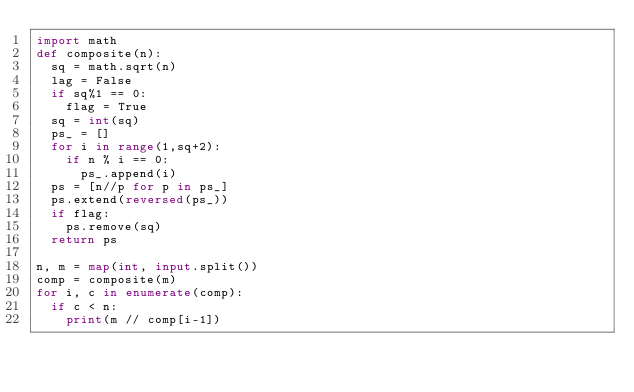<code> <loc_0><loc_0><loc_500><loc_500><_Python_>import math
def composite(n):
  sq = math.sqrt(n)
  lag = False
  if sq%1 == 0:
    flag = True
  sq = int(sq)
  ps_ = []
  for i in range(1,sq+2):
    if n % i == 0:
      ps_.append(i)
  ps = [n//p for p in ps_]
  ps.extend(reversed(ps_))
  if flag:
    ps.remove(sq)
  return ps

n, m = map(int, input.split())
comp = composite(m)
for i, c in enumerate(comp):
  if c < n:
    print(m // comp[i-1])
</code> 